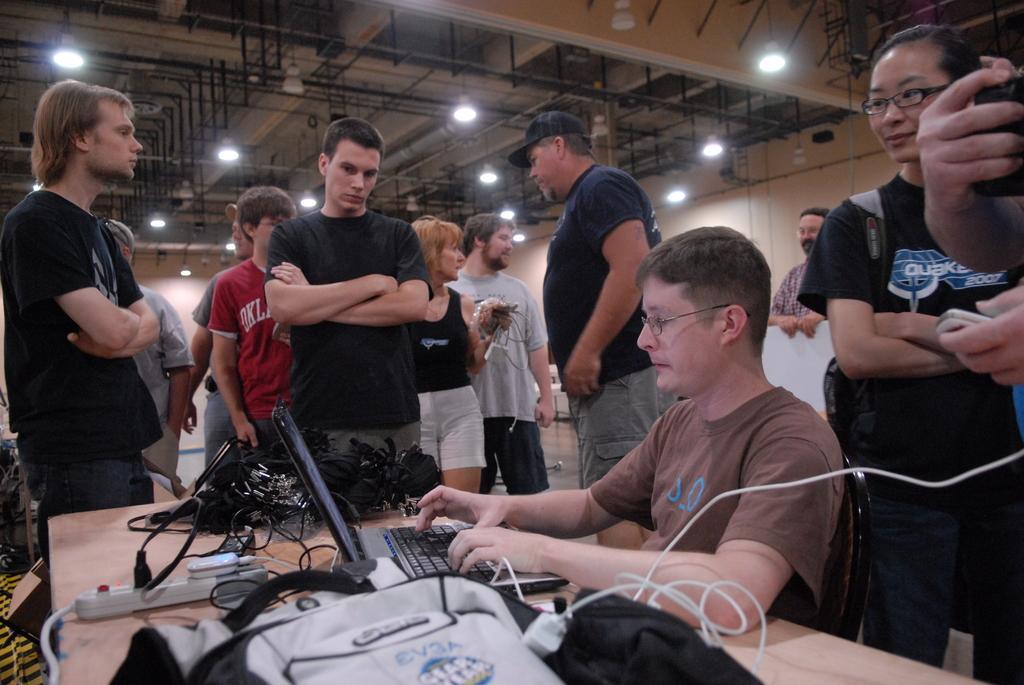Could you give a brief overview of what you see in this image? In this image there is a person standing towards the left, he is wearing a black T-shirt. Towards right there is a person sitting on the chair, he is operating laptop. There is a black and white bag on the table,there are few headsets on the table. There is a lady holding the headset in the background. There is a light at the top. 